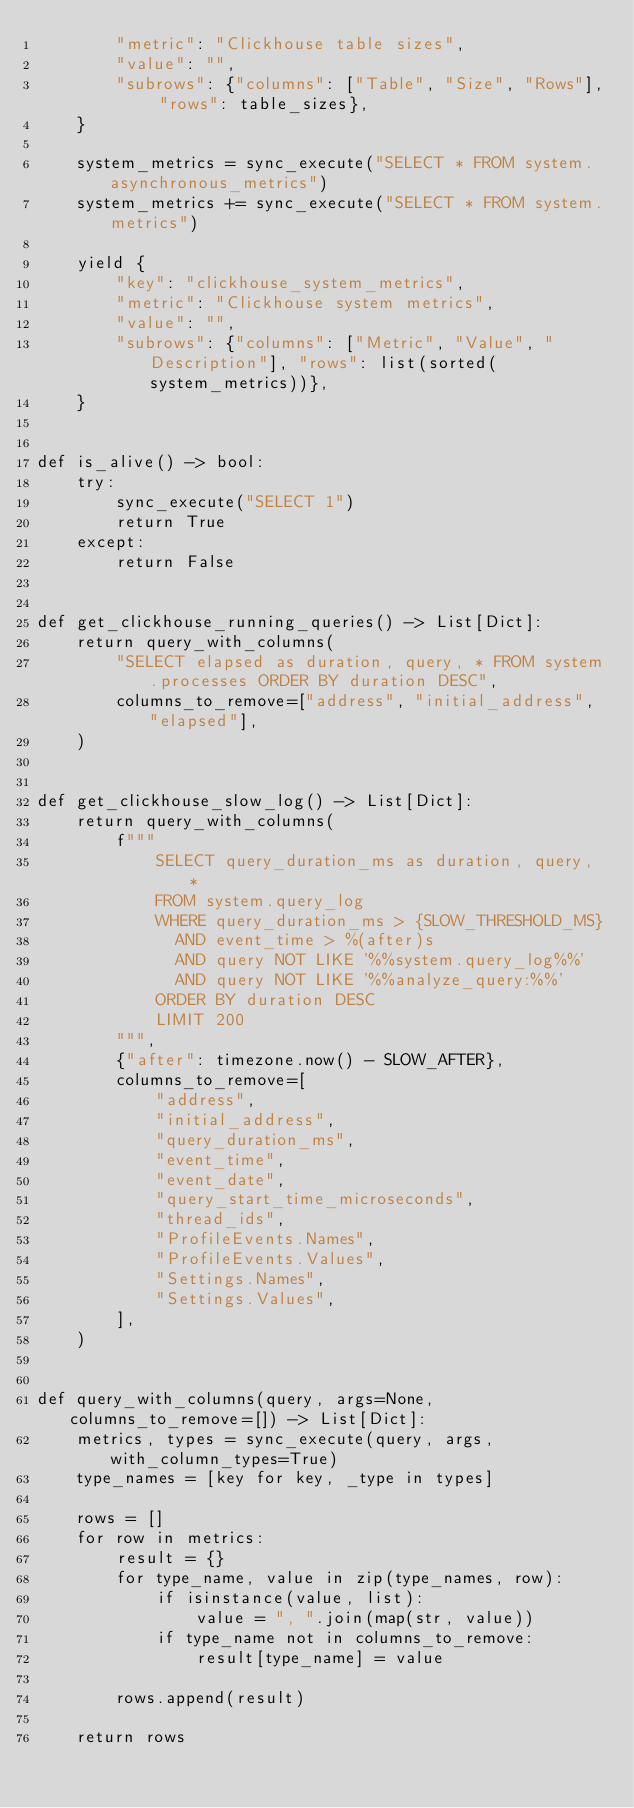Convert code to text. <code><loc_0><loc_0><loc_500><loc_500><_Python_>        "metric": "Clickhouse table sizes",
        "value": "",
        "subrows": {"columns": ["Table", "Size", "Rows"], "rows": table_sizes},
    }

    system_metrics = sync_execute("SELECT * FROM system.asynchronous_metrics")
    system_metrics += sync_execute("SELECT * FROM system.metrics")

    yield {
        "key": "clickhouse_system_metrics",
        "metric": "Clickhouse system metrics",
        "value": "",
        "subrows": {"columns": ["Metric", "Value", "Description"], "rows": list(sorted(system_metrics))},
    }


def is_alive() -> bool:
    try:
        sync_execute("SELECT 1")
        return True
    except:
        return False


def get_clickhouse_running_queries() -> List[Dict]:
    return query_with_columns(
        "SELECT elapsed as duration, query, * FROM system.processes ORDER BY duration DESC",
        columns_to_remove=["address", "initial_address", "elapsed"],
    )


def get_clickhouse_slow_log() -> List[Dict]:
    return query_with_columns(
        f"""
            SELECT query_duration_ms as duration, query, *
            FROM system.query_log
            WHERE query_duration_ms > {SLOW_THRESHOLD_MS}
              AND event_time > %(after)s
              AND query NOT LIKE '%%system.query_log%%'
              AND query NOT LIKE '%%analyze_query:%%'
            ORDER BY duration DESC
            LIMIT 200
        """,
        {"after": timezone.now() - SLOW_AFTER},
        columns_to_remove=[
            "address",
            "initial_address",
            "query_duration_ms",
            "event_time",
            "event_date",
            "query_start_time_microseconds",
            "thread_ids",
            "ProfileEvents.Names",
            "ProfileEvents.Values",
            "Settings.Names",
            "Settings.Values",
        ],
    )


def query_with_columns(query, args=None, columns_to_remove=[]) -> List[Dict]:
    metrics, types = sync_execute(query, args, with_column_types=True)
    type_names = [key for key, _type in types]

    rows = []
    for row in metrics:
        result = {}
        for type_name, value in zip(type_names, row):
            if isinstance(value, list):
                value = ", ".join(map(str, value))
            if type_name not in columns_to_remove:
                result[type_name] = value

        rows.append(result)

    return rows

</code> 